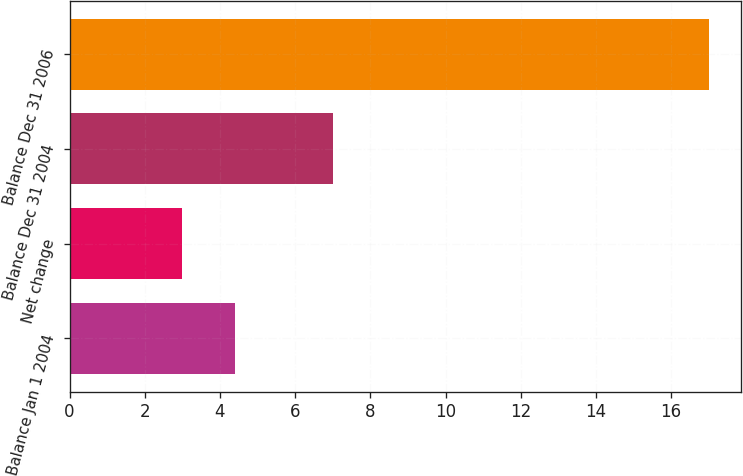<chart> <loc_0><loc_0><loc_500><loc_500><bar_chart><fcel>Balance Jan 1 2004<fcel>Net change<fcel>Balance Dec 31 2004<fcel>Balance Dec 31 2006<nl><fcel>4.4<fcel>3<fcel>7<fcel>17<nl></chart> 